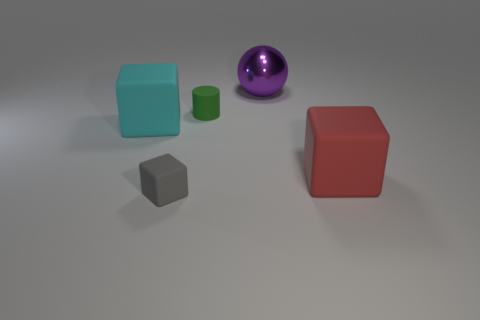Is there anything else that has the same shape as the big purple object?
Make the answer very short. No. There is a thing that is behind the red matte thing and in front of the tiny green cylinder; what is its color?
Your answer should be very brief. Cyan. What number of blocks are either big things or gray rubber things?
Make the answer very short. 3. What number of blue rubber cylinders are the same size as the green rubber cylinder?
Make the answer very short. 0. There is a big object that is in front of the big cyan rubber block; how many cyan things are behind it?
Your answer should be very brief. 1. How big is the block that is right of the large cyan thing and left of the purple sphere?
Offer a very short reply. Small. Is the number of big cyan things greater than the number of tiny brown cylinders?
Offer a very short reply. Yes. There is a green rubber cylinder to the left of the red block; is its size the same as the big metallic sphere?
Make the answer very short. No. Are there fewer big rubber cubes than red rubber cubes?
Provide a short and direct response. No. Are there any big cyan objects that have the same material as the small cube?
Offer a terse response. Yes. 